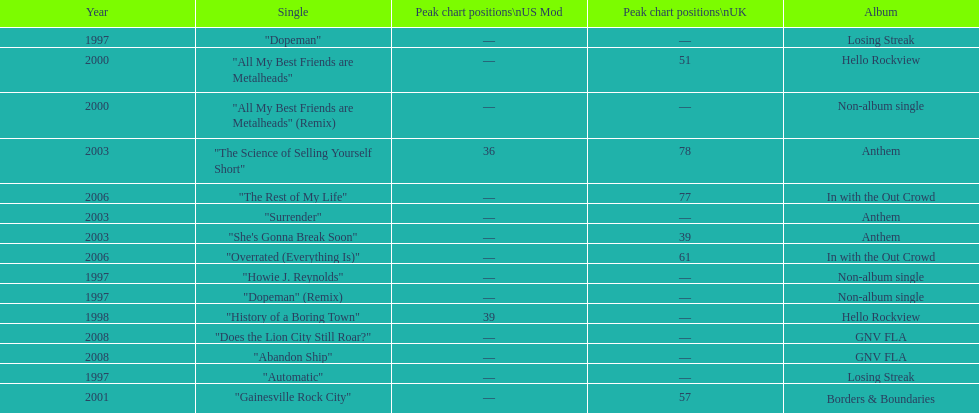What was the next single after "overrated (everything is)"? "The Rest of My Life". 